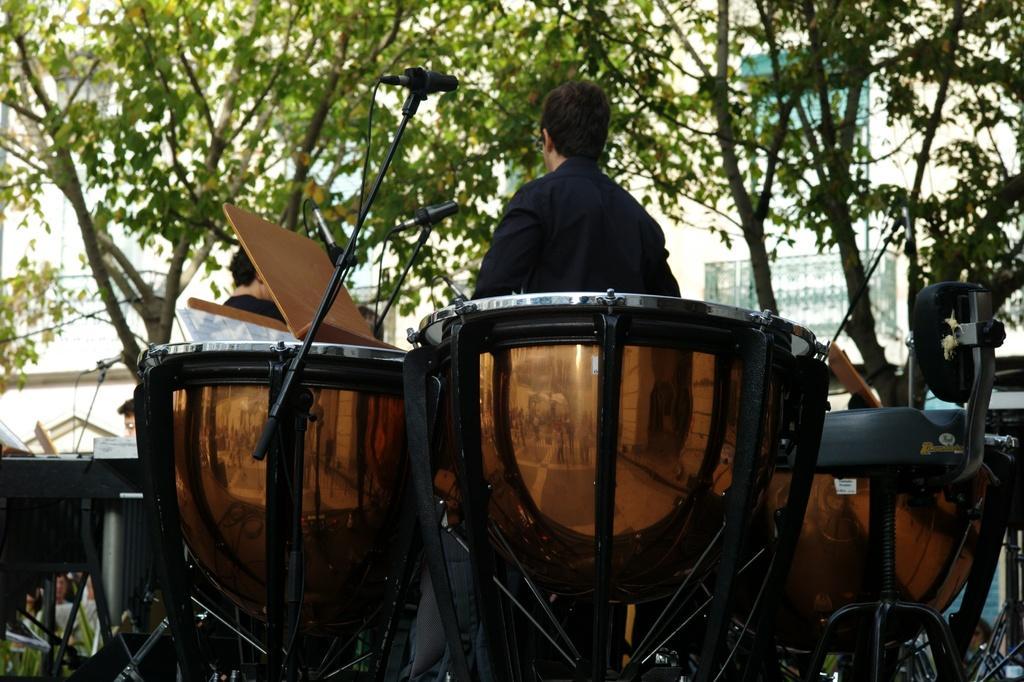Describe this image in one or two sentences. In this image there is a building, there are trees towards the top of the image, there is a wall towards the left of the image, there are three men, there are musical instruments, there are stands towards the bottom of the image, there are microphones, there are wires, the background of the image is white in color. 